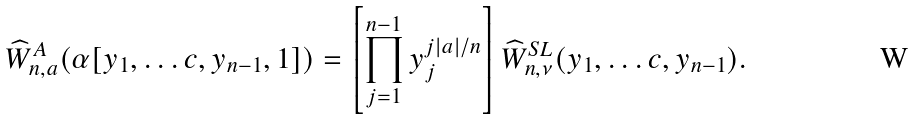Convert formula to latex. <formula><loc_0><loc_0><loc_500><loc_500>\widehat { W } _ { n , a } ^ { A } ( \alpha [ y _ { 1 } , \dots c , y _ { n - 1 } , 1 ] ) & = \left [ \prod _ { j = 1 } ^ { n - 1 } y _ { j } ^ { { j | a | } / { n } } \right ] \widehat { W } _ { n , \nu } ^ { S L } ( y _ { 1 } , \dots c , y _ { n - 1 } ) .</formula> 